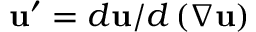Convert formula to latex. <formula><loc_0><loc_0><loc_500><loc_500>u ^ { \prime } = d u / d \left ( \nabla u \right )</formula> 